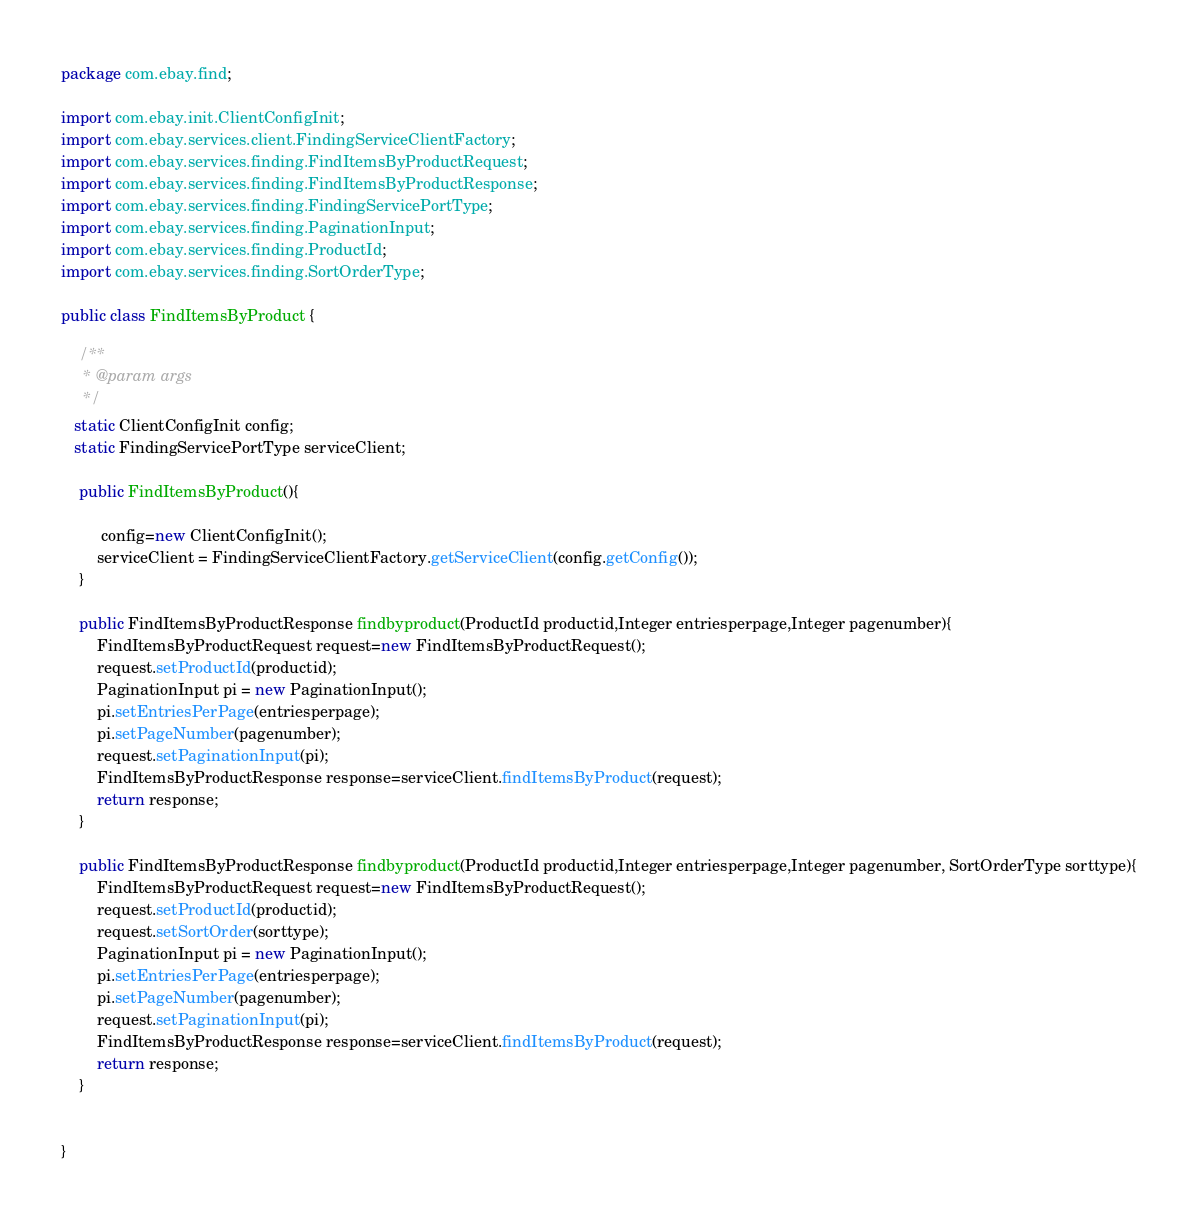<code> <loc_0><loc_0><loc_500><loc_500><_Java_>package com.ebay.find;

import com.ebay.init.ClientConfigInit;
import com.ebay.services.client.FindingServiceClientFactory;
import com.ebay.services.finding.FindItemsByProductRequest;
import com.ebay.services.finding.FindItemsByProductResponse;
import com.ebay.services.finding.FindingServicePortType;
import com.ebay.services.finding.PaginationInput;
import com.ebay.services.finding.ProductId;
import com.ebay.services.finding.SortOrderType;

public class FindItemsByProduct {

	/**
	 * @param args
	 */
   static ClientConfigInit config;
   static FindingServicePortType serviceClient;
  	
	public FindItemsByProduct(){
  		
  		 config=new ClientConfigInit();
  		serviceClient = FindingServiceClientFactory.getServiceClient(config.getConfig());
  	}
	
	public FindItemsByProductResponse findbyproduct(ProductId productid,Integer entriesperpage,Integer pagenumber){
		FindItemsByProductRequest request=new FindItemsByProductRequest();
		request.setProductId(productid);
		PaginationInput pi = new PaginationInput();
	    pi.setEntriesPerPage(entriesperpage);
	    pi.setPageNumber(pagenumber);
	    request.setPaginationInput(pi);
	    FindItemsByProductResponse response=serviceClient.findItemsByProduct(request);
		return response;
	}
	
	public FindItemsByProductResponse findbyproduct(ProductId productid,Integer entriesperpage,Integer pagenumber, SortOrderType sorttype){
		FindItemsByProductRequest request=new FindItemsByProductRequest();
		request.setProductId(productid);
        request.setSortOrder(sorttype);
		PaginationInput pi = new PaginationInput();
	    pi.setEntriesPerPage(entriesperpage);
	    pi.setPageNumber(pagenumber);
	    request.setPaginationInput(pi);
	    FindItemsByProductResponse response=serviceClient.findItemsByProduct(request);
		return response;
	}
	
	
}
</code> 